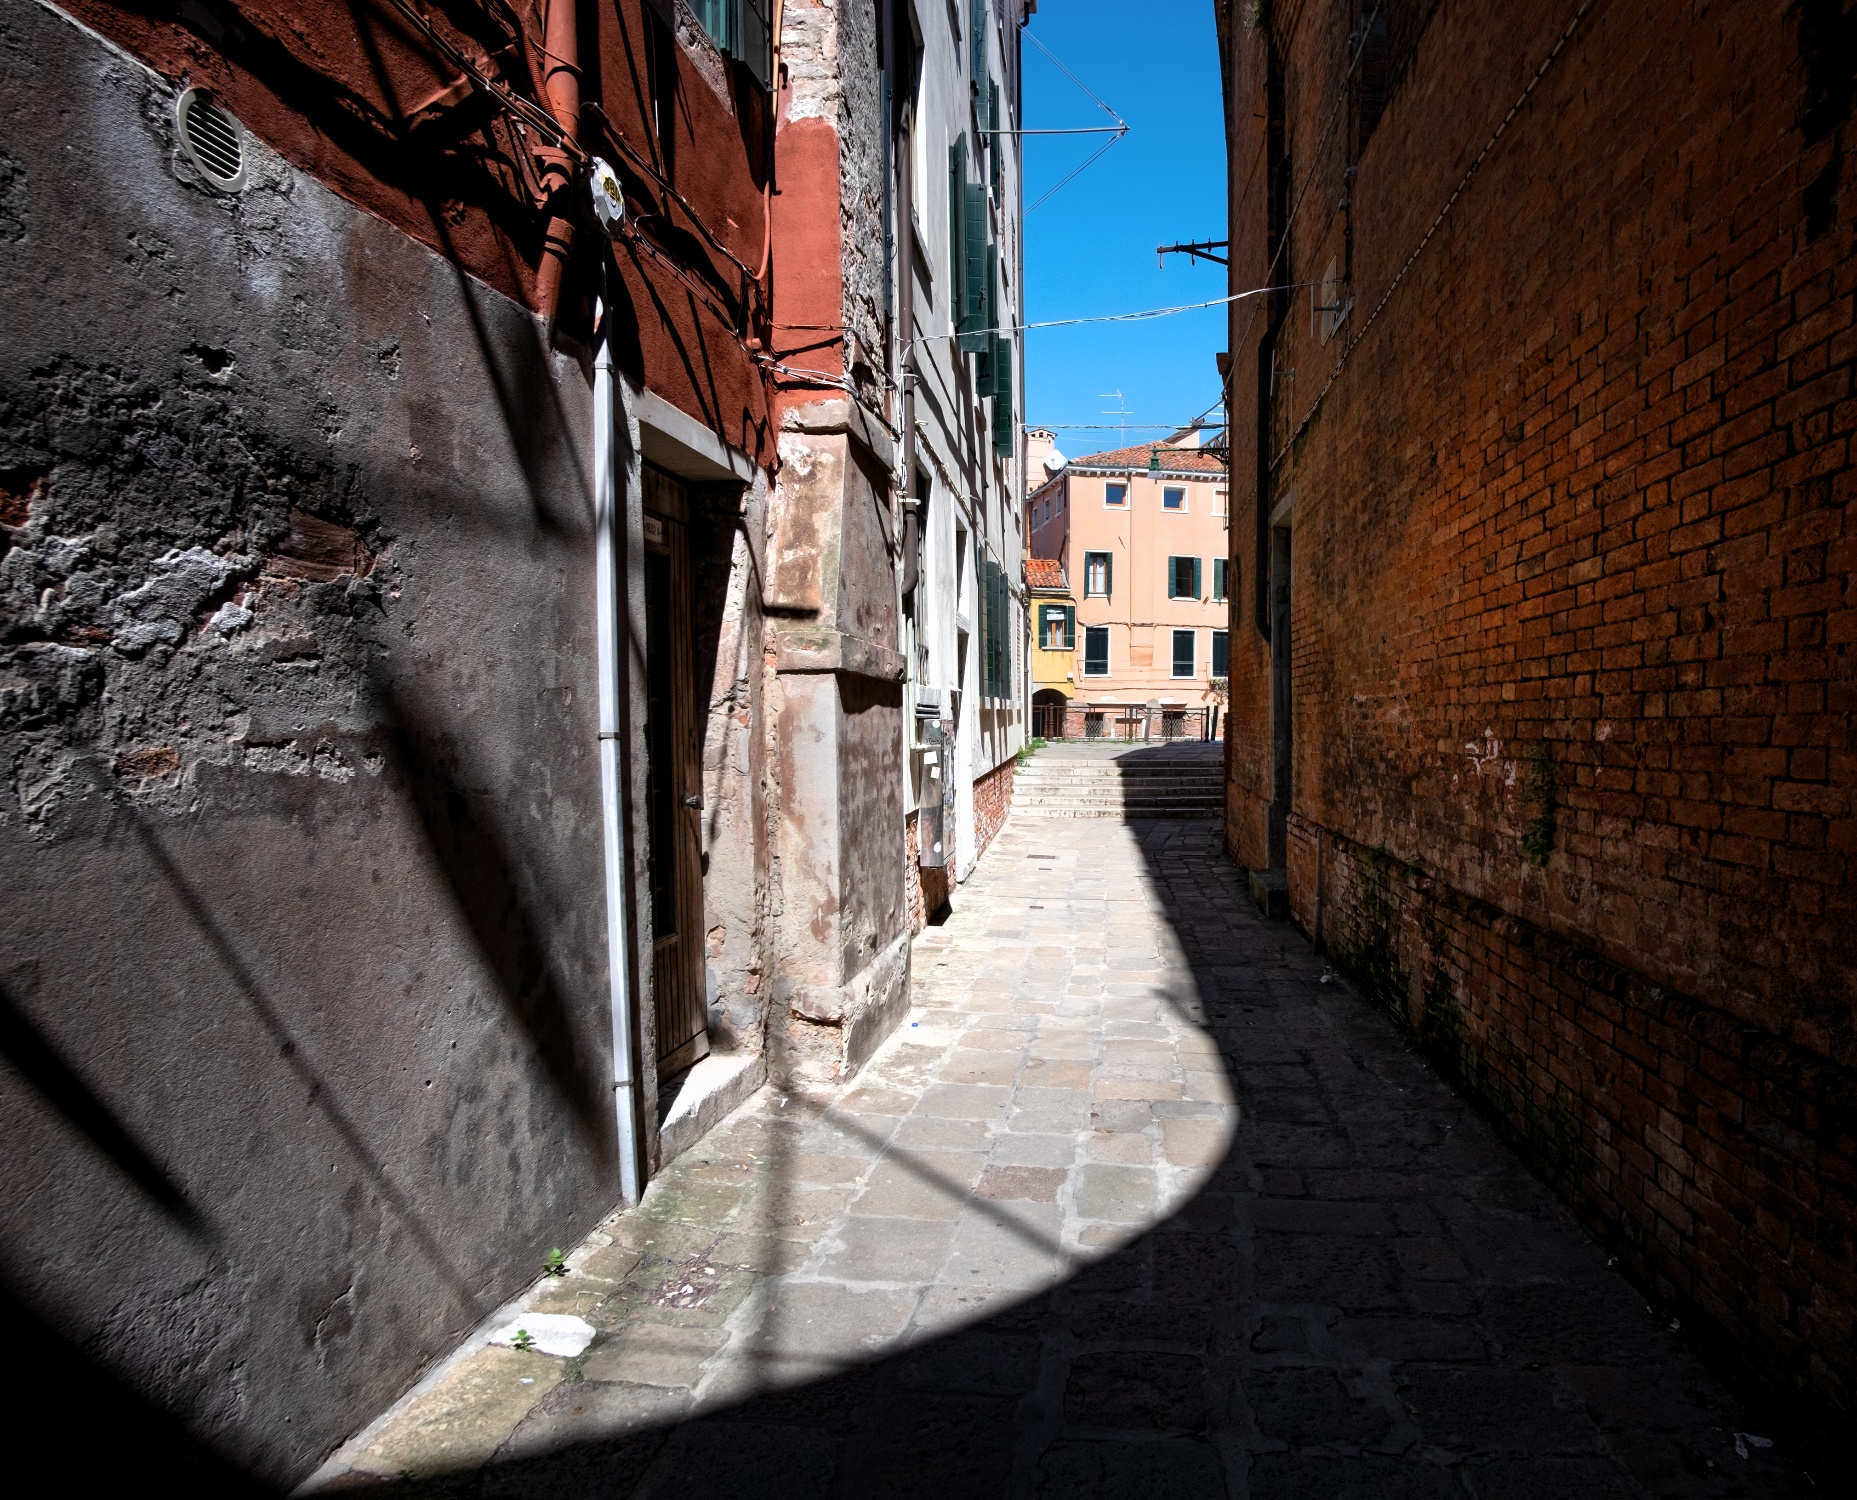Imagine an animated movie scene set in this alleyway. What would happen? In an animated movie, this alleyway could serve as a secret, magical pathway. As the protagonist, perhaps a young adventurer, steps into the alley, the cobblestones might start to glow, lighting up a hidden map that leads them on an extraordinary quest. The old brick buildings could reveal enchanted murals that move and narrate the history of a lost treasure. Clotheslines might carry notes or messages from an ancient society. As the protagonist makes their way through, they encounter whimsical characters like talking cats, shadowy figures from a fantastical world, and obstacles that test their courage. The sky, which starts as a bright blue, might occasionally swirl with mystical colors, indicating shifts in the magical energy surrounding the alley. Every corner of this alleyway would hold a new surprise, transforming each step into an adventure filled with wonder and excitement. 